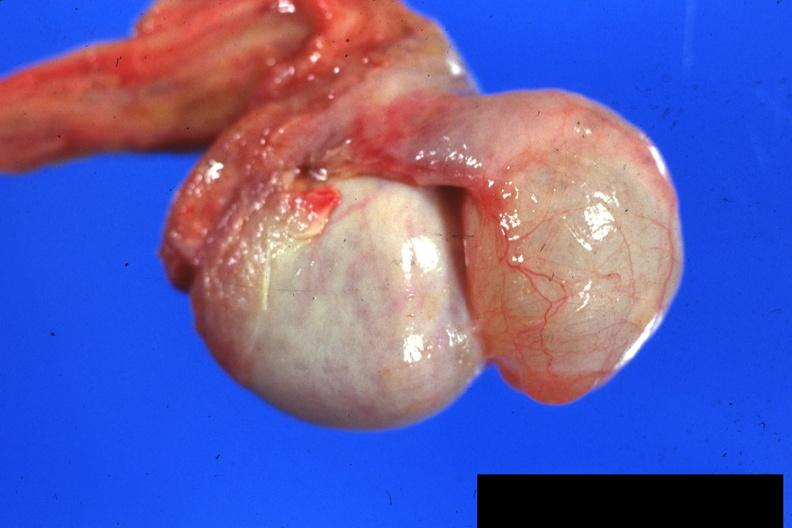s testicle present?
Answer the question using a single word or phrase. Yes 